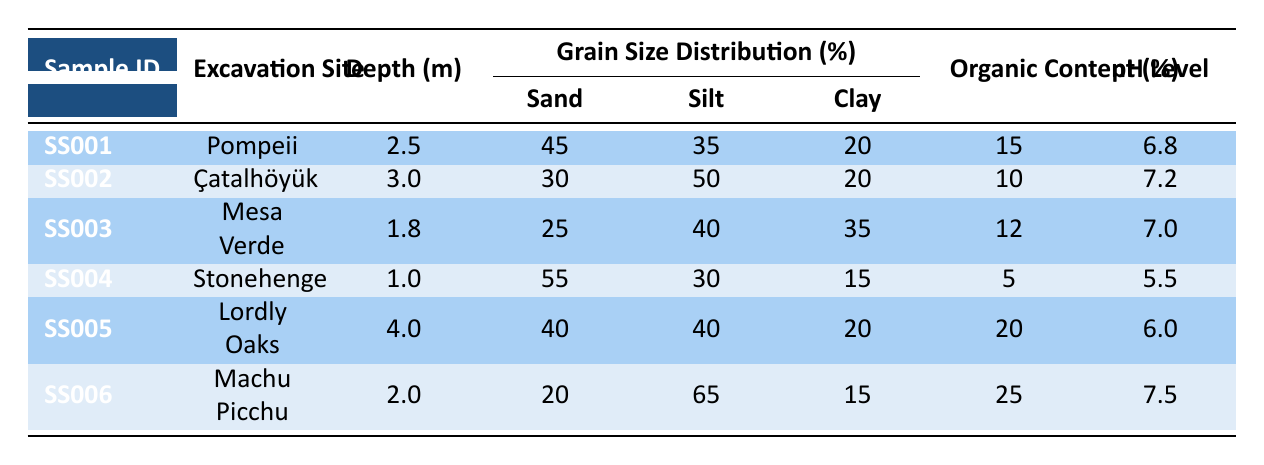What excavation site has the highest organic content? Looking at the organic content percentage for each site, Lordly Oaks has 20%, Machu Picchu has 25%, Pompeii has 15%, Çatalhöyük has 10%, Mesa Verde has 12%, and Stonehenge has 5%. Therefore, Machu Picchu has the highest organic content at 25%.
Answer: Machu Picchu Which site has the lowest pH level? Reviewing the pH levels for each site, Stonehenge has a pH level of 5.5, while the others have higher levels: Pompeii at 6.8, Çatalhöyük at 7.2, Mesa Verde at 7.0, Lordly Oaks at 6.0, and Machu Picchu at 7.5. Therefore, Stonehenge has the lowest pH level.
Answer: Stonehenge What is the total sand fraction percentage across all sites? Collecting the sand fractions: Pompeii has 45%, Çatalhöyük has 30%, Mesa Verde has 25%, Stonehenge has 55%, Lordly Oaks has 40%, and Machu Picchu has 20%. We add these together: 45 + 30 + 25 + 55 + 40 + 20 = 215%.
Answer: 215% Do any excavation sites exhibit high microbial activity? Checking for microbial activity levels, we see that Çatalhöyük and Lordly Oaks have "High" activity, while Pompeii and Machu Picchu have "Moderate," and Mesa Verde has "Low," while Stonehenge has "Very Low." Thus, both Çatalhöyük and Lordly Oaks exhibit high microbial activity.
Answer: Yes What is the average depth of the samples from the sites? The depths are: Pompeii 2.5m, Çatalhöyük 3.0m, Mesa Verde 1.8m, Stonehenge 1.0m, Lordly Oaks 4.0m, and Machu Picchu 2.0m. First, we sum the depths: 2.5 + 3.0 + 1.8 + 1.0 + 4.0 + 2.0 = 14.3m, and then divide by the number of samples (6): 14.3 / 6 = approximately 2.38m.
Answer: 2.38m Which excavation site has both the highest pH level and the highest clay fraction? Analyzing the sites: Machu Picchu has the highest pH level at 7.5 but a clay fraction of 15%. Çatalhöyük's clay fraction is 20% with a pH of 7.2. Stonehenge has the lowest pH but a clay fraction of 15%. Highest pH level goes to Machu Picchu, but highest clay fraction is in Çatalhöyük. Hence, no site has both qualities simultaneously.
Answer: None 